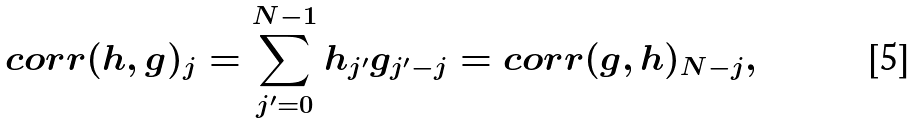<formula> <loc_0><loc_0><loc_500><loc_500>c o r r ( h , g ) _ { j } = \sum _ { j ^ { \prime } = 0 } ^ { N - 1 } h _ { j ^ { \prime } } g _ { j ^ { \prime } - j } = c o r r ( g , h ) _ { N - j } ,</formula> 